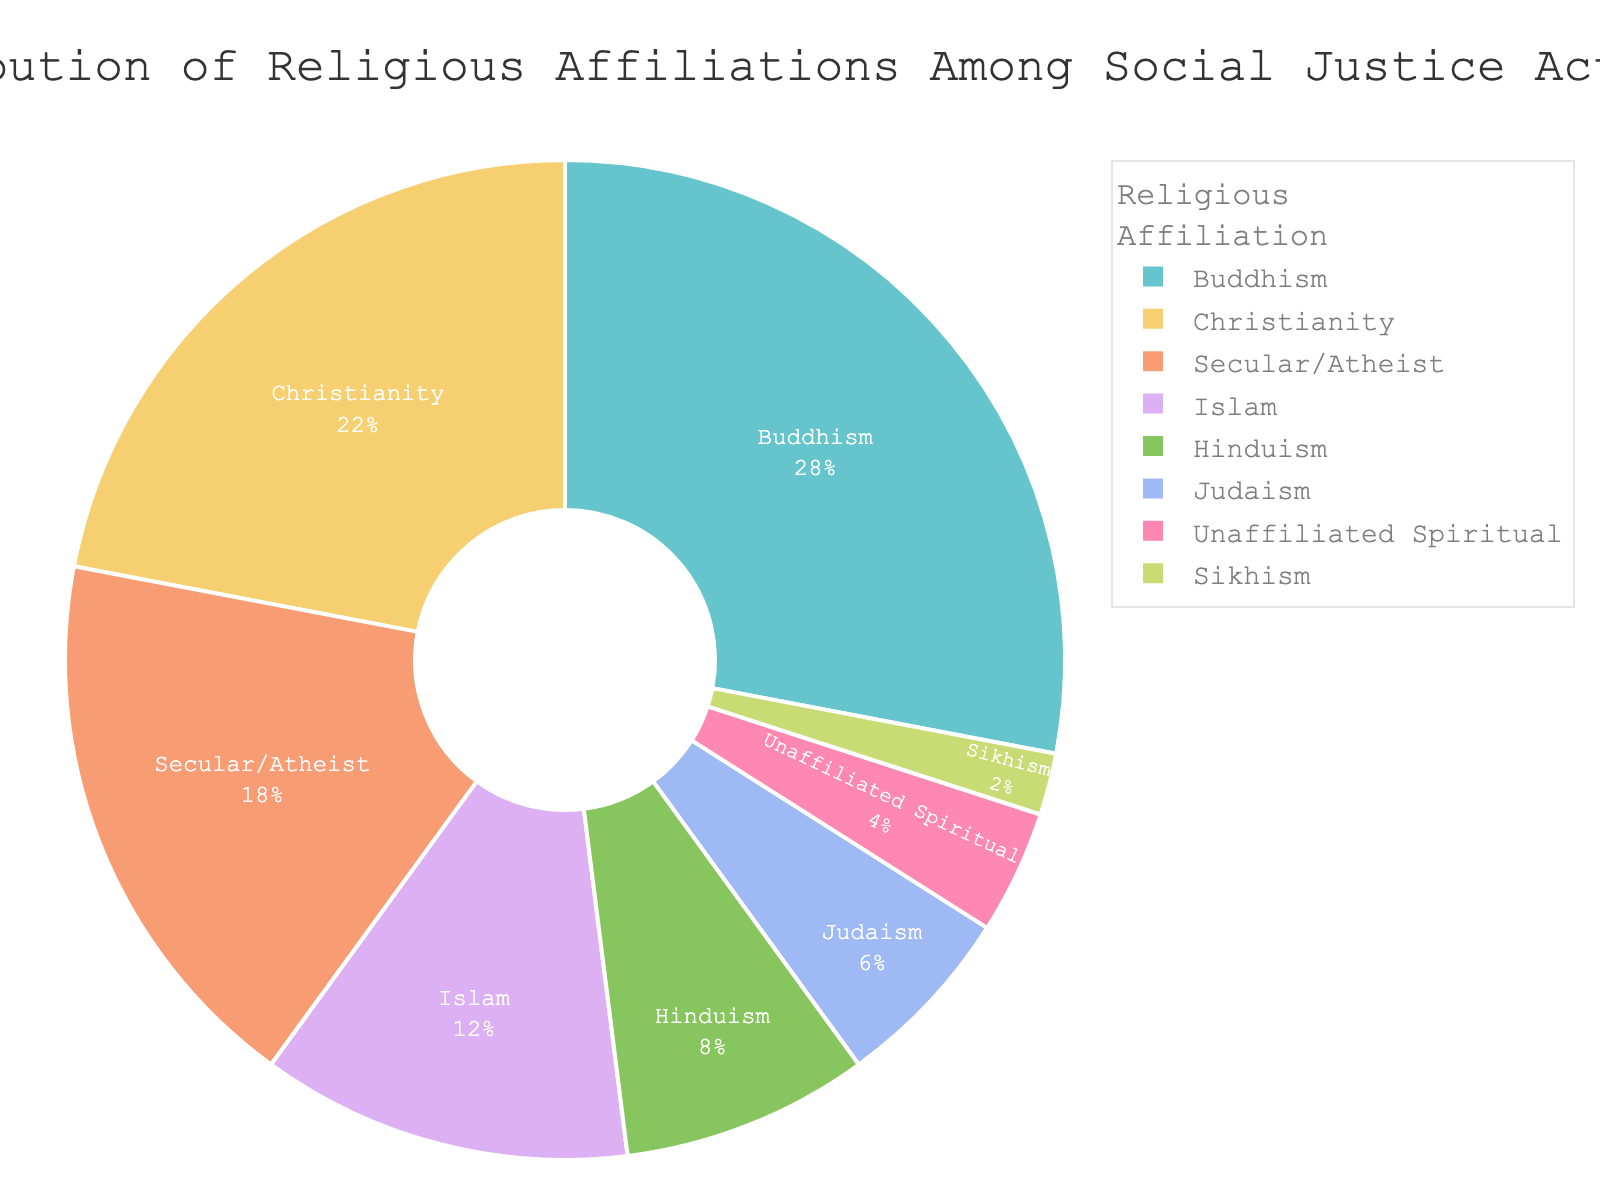What percentage of social justice activists are either Christian or Muslim? The chart shows that Christians make up 22% and Muslims make up 12% of social justice activists. Adding these percentages together: 22% + 12% = 34%
Answer: 34% Which religious affiliation has the smallest representation among social justice activists? The smallest section of the pie chart represents Sikhism, which has a percentage of 2%. This can be seen from the chart.
Answer: Sikhism How does the percentage of atheists compare to that of Hindus? The chart shows that Secular/Atheist activists make up 18%, while Hindu activists make up 8%. Comparing these percentages: 18% is greater than 8%.
Answer: Secular/Atheist has a higher percentage What is the combined percentage of Unaffiliated Spiritual and Secular/Atheist activists? The chart shows that Unaffiliated Spiritual activists make up 4% and Secular/Atheist activists make up 18%. Adding these percentages together: 4% + 18% = 22%
Answer: 22% What percentage of activists identify with religions other than Buddhism, Christianity, and Secular/Atheist? Sum the percentages of Islam (12%), Hinduism (8%), Judaism (6%), Unaffiliated Spiritual (4%), and Sikhism (2%): 12% + 8% + 6% + 4% + 2% = 32%
Answer: 32% Which religious affiliation section appears to take up the most space in the pie chart? By visually inspecting the pie chart, the section for Buddhism appears to be the largest with 28% of activists identifying with it.
Answer: Buddhism Does the percentage of Buddhist activists exceed the combined percentage of Jewish and Hindu activists? The chart shows that Buddhist activists make up 28%, Jewish activists make up 6%, and Hindu activists make up 8%. Adding Jewish and Hindu percentages: 6% + 8% = 14%. Comparing these, 28% is greater than 14%.
Answer: Yes What is the percentage difference between Christians and the Unaffiliated Spiritual activists? The chart shows Christians at 22% and Unaffiliated Spiritual at 4%. Subtracting the Unaffiliated Spiritual percentage from the Christian percentage: 22% - 4% = 18%
Answer: 18% If we combine the percentages of Christianity, Hinduism, and Judaism, do they surpass the percentage of Buddhism? The sum of the percentages for Christianity (22%), Hinduism (8%), and Judaism (6%) is: 22% + 8% + 6% = 36%. This surpasses the 28% of Buddhism.
Answer: Yes How much greater is the percentage of Buddhism compared to Islam? The chart shows that Buddhists make up 28%, and Muslims make up 12%. Subtracting the percentage of Islam from Buddhism: 28% - 12% = 16%
Answer: 16% 